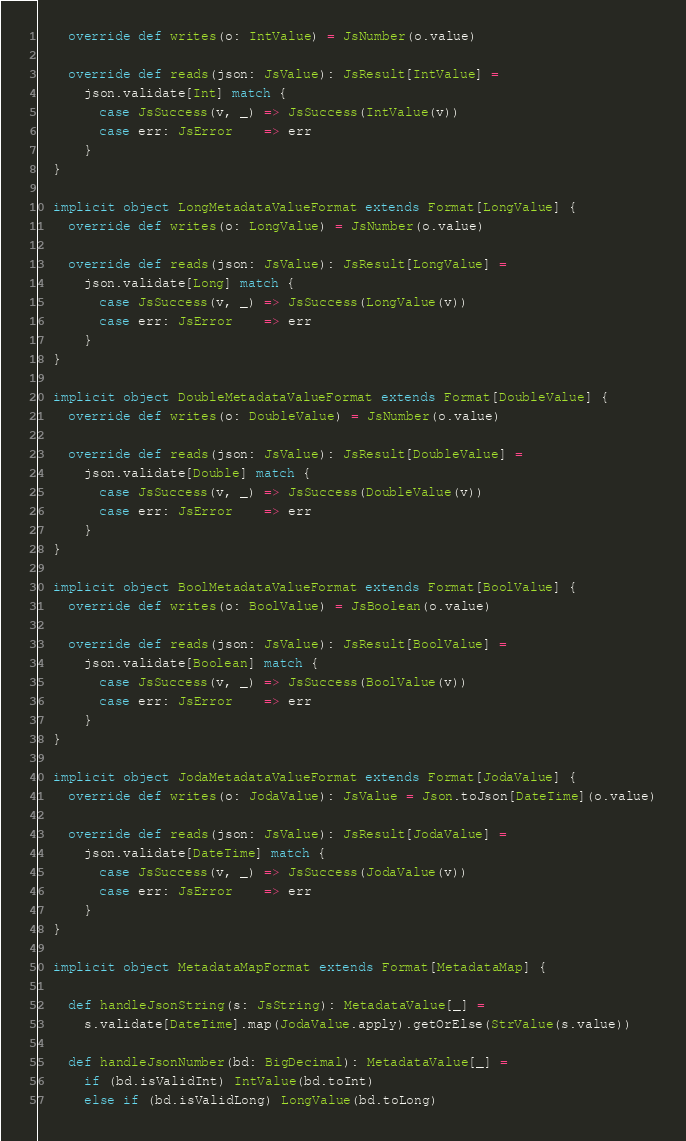<code> <loc_0><loc_0><loc_500><loc_500><_Scala_>    override def writes(o: IntValue) = JsNumber(o.value)

    override def reads(json: JsValue): JsResult[IntValue] =
      json.validate[Int] match {
        case JsSuccess(v, _) => JsSuccess(IntValue(v))
        case err: JsError    => err
      }
  }

  implicit object LongMetadataValueFormat extends Format[LongValue] {
    override def writes(o: LongValue) = JsNumber(o.value)

    override def reads(json: JsValue): JsResult[LongValue] =
      json.validate[Long] match {
        case JsSuccess(v, _) => JsSuccess(LongValue(v))
        case err: JsError    => err
      }
  }

  implicit object DoubleMetadataValueFormat extends Format[DoubleValue] {
    override def writes(o: DoubleValue) = JsNumber(o.value)

    override def reads(json: JsValue): JsResult[DoubleValue] =
      json.validate[Double] match {
        case JsSuccess(v, _) => JsSuccess(DoubleValue(v))
        case err: JsError    => err
      }
  }

  implicit object BoolMetadataValueFormat extends Format[BoolValue] {
    override def writes(o: BoolValue) = JsBoolean(o.value)

    override def reads(json: JsValue): JsResult[BoolValue] =
      json.validate[Boolean] match {
        case JsSuccess(v, _) => JsSuccess(BoolValue(v))
        case err: JsError    => err
      }
  }

  implicit object JodaMetadataValueFormat extends Format[JodaValue] {
    override def writes(o: JodaValue): JsValue = Json.toJson[DateTime](o.value)

    override def reads(json: JsValue): JsResult[JodaValue] =
      json.validate[DateTime] match {
        case JsSuccess(v, _) => JsSuccess(JodaValue(v))
        case err: JsError    => err
      }
  }

  implicit object MetadataMapFormat extends Format[MetadataMap] {

    def handleJsonString(s: JsString): MetadataValue[_] =
      s.validate[DateTime].map(JodaValue.apply).getOrElse(StrValue(s.value))

    def handleJsonNumber(bd: BigDecimal): MetadataValue[_] =
      if (bd.isValidInt) IntValue(bd.toInt)
      else if (bd.isValidLong) LongValue(bd.toLong)</code> 